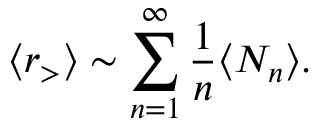Convert formula to latex. <formula><loc_0><loc_0><loc_500><loc_500>\langle r _ { > } \rangle \sim \sum _ { n = 1 } ^ { \infty } \frac { 1 } { n } \langle N _ { n } \rangle .</formula> 